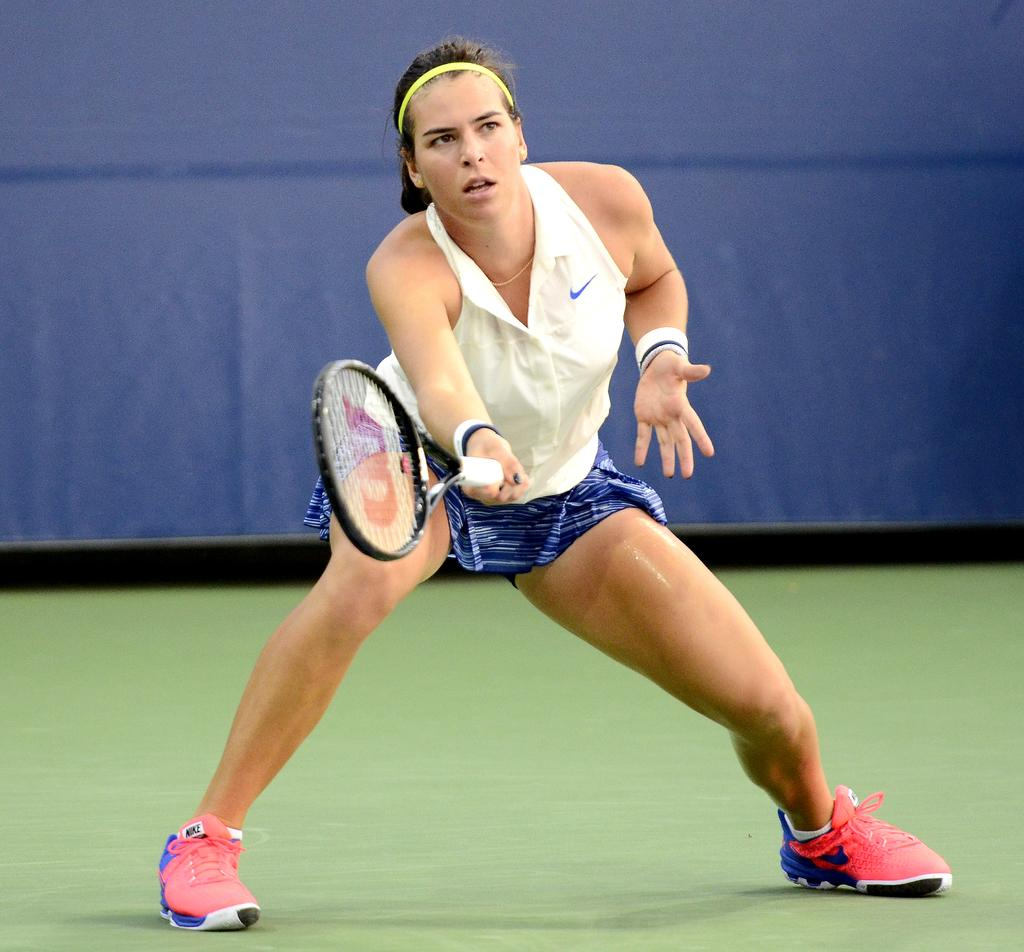Who is present in the image? There is a person in the image. What is the person holding in the image? The person is holding a racket. Where is the person located in the image? The person is on the ground. What can be seen in the background of the image? There is a blue sheet in the background of the image. What type of plastic is covering the apples in the image? There are no apples or plastic present in the image. 